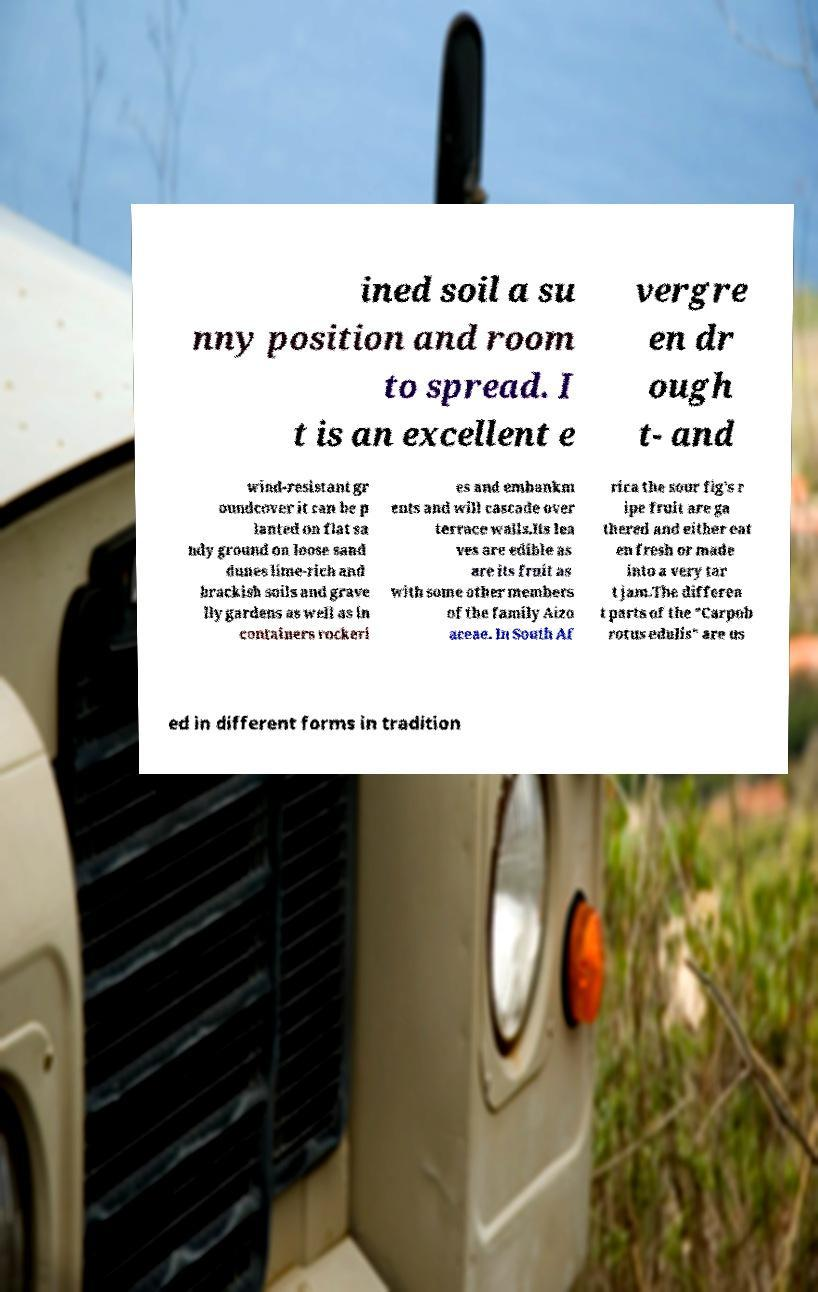For documentation purposes, I need the text within this image transcribed. Could you provide that? ined soil a su nny position and room to spread. I t is an excellent e vergre en dr ough t- and wind-resistant gr oundcover it can be p lanted on flat sa ndy ground on loose sand dunes lime-rich and brackish soils and grave lly gardens as well as in containers rockeri es and embankm ents and will cascade over terrace walls.Its lea ves are edible as are its fruit as with some other members of the family Aizo aceae. In South Af rica the sour fig's r ipe fruit are ga thered and either eat en fresh or made into a very tar t jam.The differen t parts of the "Carpob rotus edulis" are us ed in different forms in tradition 